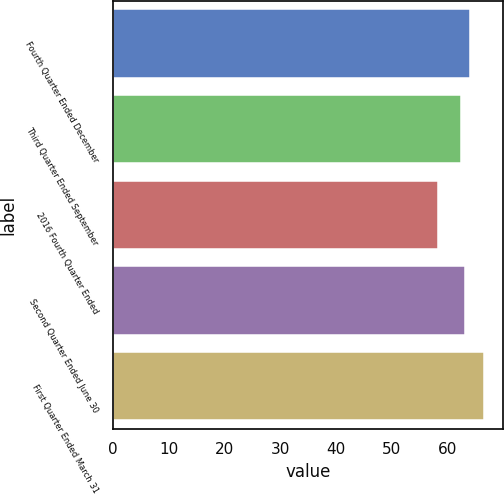<chart> <loc_0><loc_0><loc_500><loc_500><bar_chart><fcel>Fourth Quarter Ended December<fcel>Third Quarter Ended September<fcel>2016 Fourth Quarter Ended<fcel>Second Quarter Ended June 30<fcel>First Quarter Ended March 31<nl><fcel>64.05<fcel>62.39<fcel>58.28<fcel>63.22<fcel>66.62<nl></chart> 